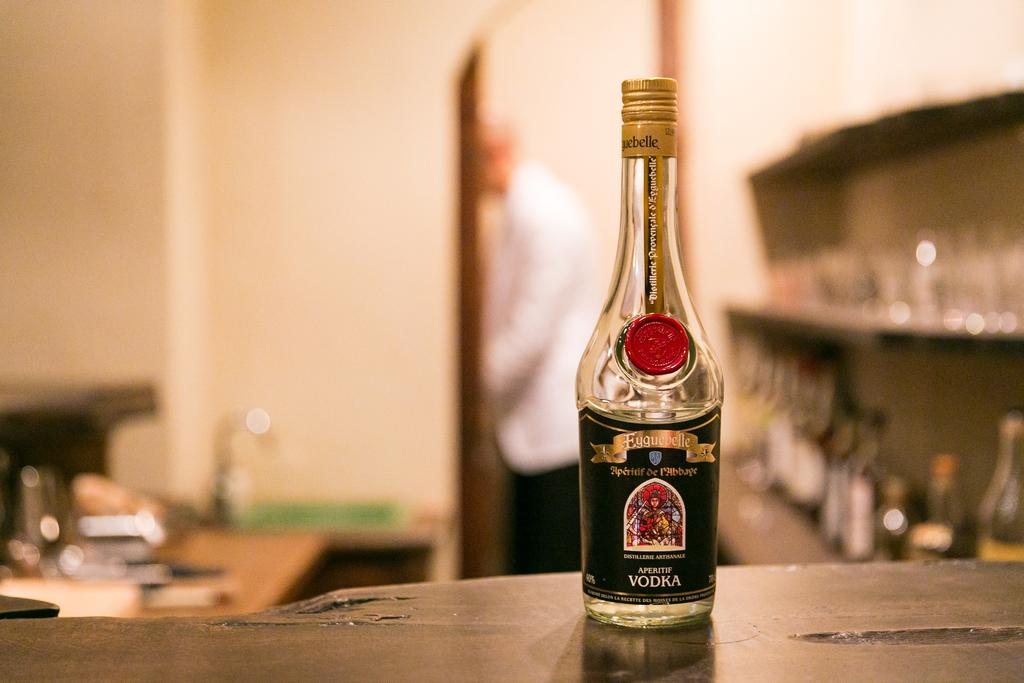What is the person in the image doing with the surfboard? The person in the image is carrying a surfboard while walking on a beach. What might the person be planning to do with the surfboard? The person might be planning to go surfing with the surfboard. What type of environment is the person in? The person is in a beach environment. What is the person wearing while walking on the beach? The person is wearing a helmet. Where is the faucet located in the image? There is no faucet present in the image; it features a person walking on a beach carrying a surfboard. 